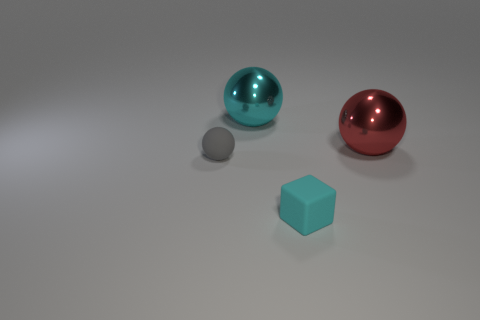Are there fewer big red things that are on the right side of the red ball than small cyan rubber things behind the tiny cyan thing?
Your answer should be very brief. No. How many brown metal things are there?
Your response must be concise. 0. Is there any other thing that is the same material as the red ball?
Your answer should be compact. Yes. There is a gray object that is the same shape as the large cyan shiny thing; what is it made of?
Keep it short and to the point. Rubber. Are there fewer red objects in front of the rubber ball than large brown metallic objects?
Ensure brevity in your answer.  No. There is a big shiny object that is right of the tiny cyan rubber thing; is it the same shape as the tiny cyan thing?
Provide a succinct answer. No. Is there anything else that is the same color as the small ball?
Offer a terse response. No. What is the size of the cyan object that is the same material as the tiny gray thing?
Offer a terse response. Small. What material is the cyan object that is behind the rubber thing to the left of the metal object that is to the left of the big red sphere made of?
Provide a short and direct response. Metal. Is the number of small blue metal balls less than the number of tiny cyan rubber cubes?
Your response must be concise. Yes. 